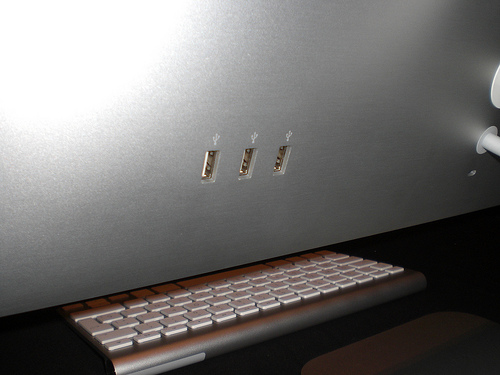<image>
Is the keyboard next to the computer? Yes. The keyboard is positioned adjacent to the computer, located nearby in the same general area. 